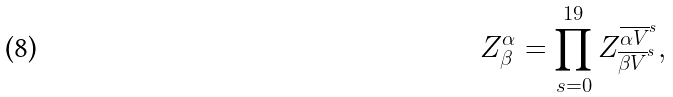<formula> <loc_0><loc_0><loc_500><loc_500>Z _ { \beta } ^ { \alpha } = \prod _ { s = 0 } ^ { 1 9 } Z _ { \overline { \beta V } ^ { s } } ^ { \overline { \alpha V } ^ { s } } ,</formula> 